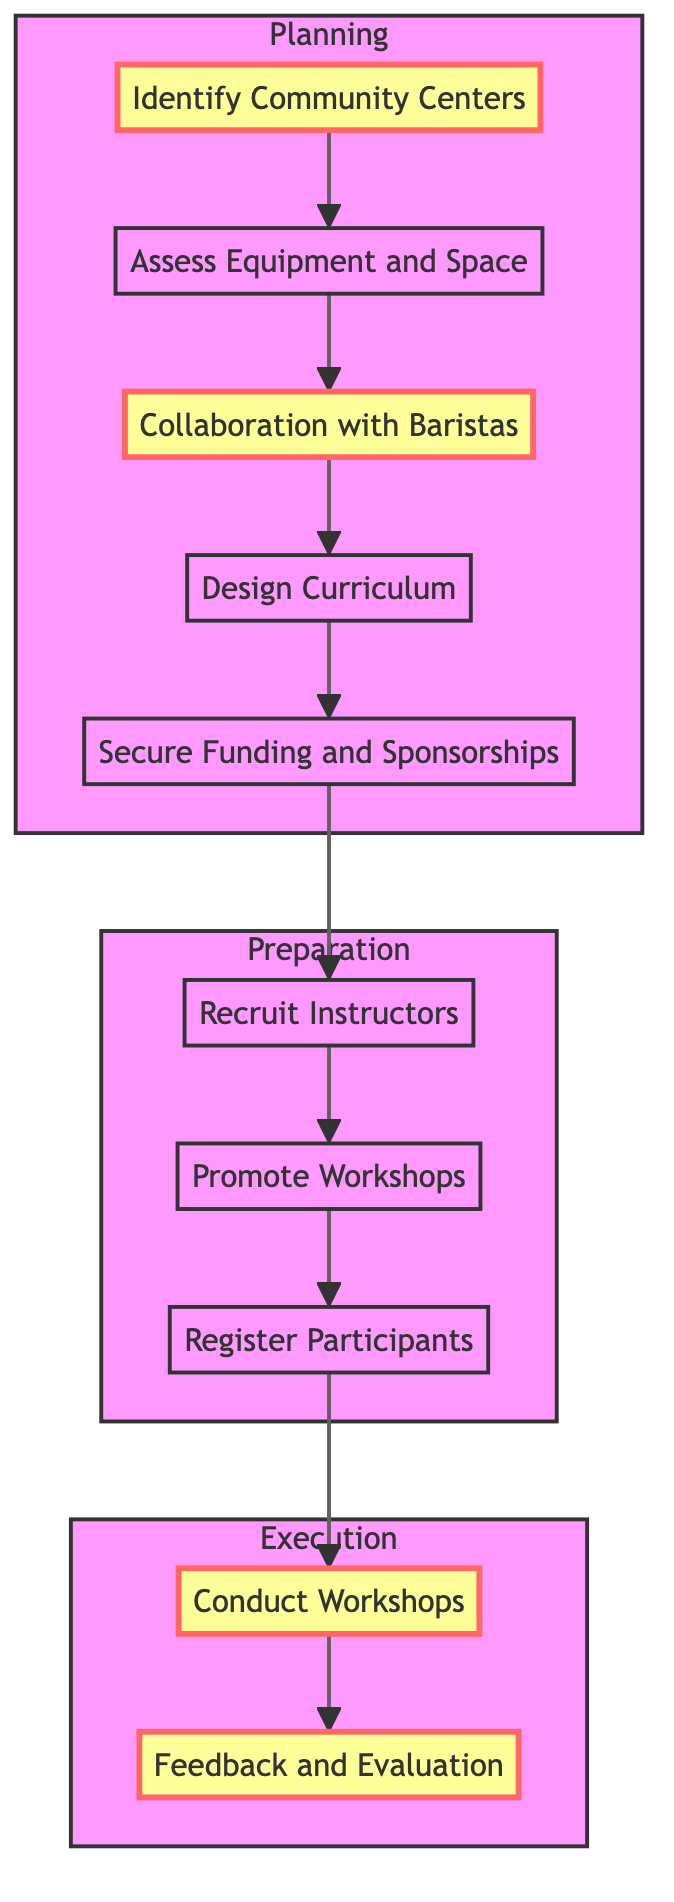What is the first step in the process? The diagram clearly shows that the first step is "Identify Community Centers," as it is the initial node at the top of the flowchart.
Answer: Identify Community Centers How many main sections are there in the flowchart? The flowchart is divided into three main sections: Planning, Preparation, and Execution, which are represented as subgraphs.
Answer: Three Which step involves securing financial support? The step "Secure Funding and Sponsorships" is responsible for finding financial support, and it follows "Design Curriculum."
Answer: Secure Funding and Sponsorships What is the last step in the instruction flow? The final step in the flowchart is "Feedback and Evaluation," which comes after "Conduct Workshops."
Answer: Feedback and Evaluation How many steps are required after Design Curriculum? There are three steps required after "Design Curriculum," which are "Secure Funding and Sponsorships," "Recruit Instructors," and "Promote Workshops."
Answer: Three What connects the "Collaboration with Baristas" to "Design Curriculum"? "Collaboration with Baristas" connects to "Design Curriculum" as a direct sequential step indicating that once collaboration is established, curriculum design follows.
Answer: Design Curriculum What is the relationship between "Register Participants" and "Promote Workshops"? "Register Participants" comes directly after "Promote Workshops," indicating that promoting the workshops happens first before the registration of participants.
Answer: Direct connection Which two steps highlight the involvement of baristas? "Collaboration with Baristas" is the specific step that brings baristas into the process, situated between "Assess Equipment and Space" and "Design Curriculum."
Answer: Collaboration with Baristas How many steps are categorized as Execution? There are two steps categorized under Execution: "Conduct Workshops" and "Feedback and Evaluation."
Answer: Two 